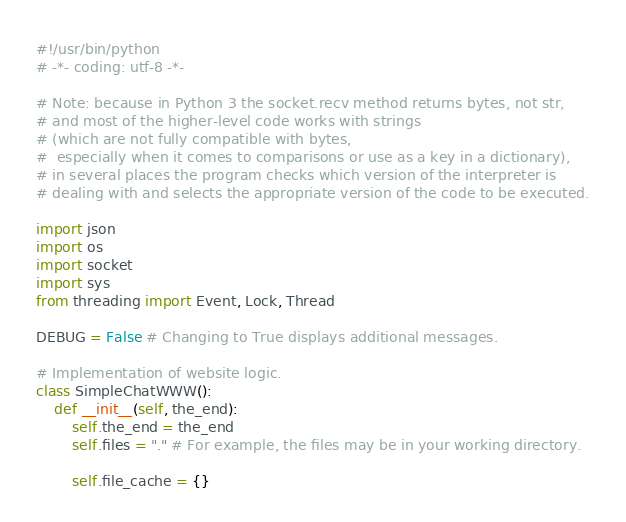Convert code to text. <code><loc_0><loc_0><loc_500><loc_500><_Python_>#!/usr/bin/python
# -*- coding: utf-8 -*-

# Note: because in Python 3 the socket.recv method returns bytes, not str,
# and most of the higher-level code works with strings
# (which are not fully compatible with bytes,
#  especially when it comes to comparisons or use as a key in a dictionary),
# in several places the program checks which version of the interpreter is
# dealing with and selects the appropriate version of the code to be executed.

import json
import os
import socket
import sys
from threading import Event, Lock, Thread

DEBUG = False # Changing to True displays additional messages.

# Implementation of website logic.
class SimpleChatWWW():
    def __init__(self, the_end):
        self.the_end = the_end
        self.files = "." # For example, the files may be in your working directory.

        self.file_cache = {}</code> 